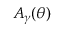Convert formula to latex. <formula><loc_0><loc_0><loc_500><loc_500>A _ { \gamma } ( \theta )</formula> 